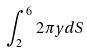<formula> <loc_0><loc_0><loc_500><loc_500>\int _ { 2 } ^ { 6 } 2 \pi y d S</formula> 